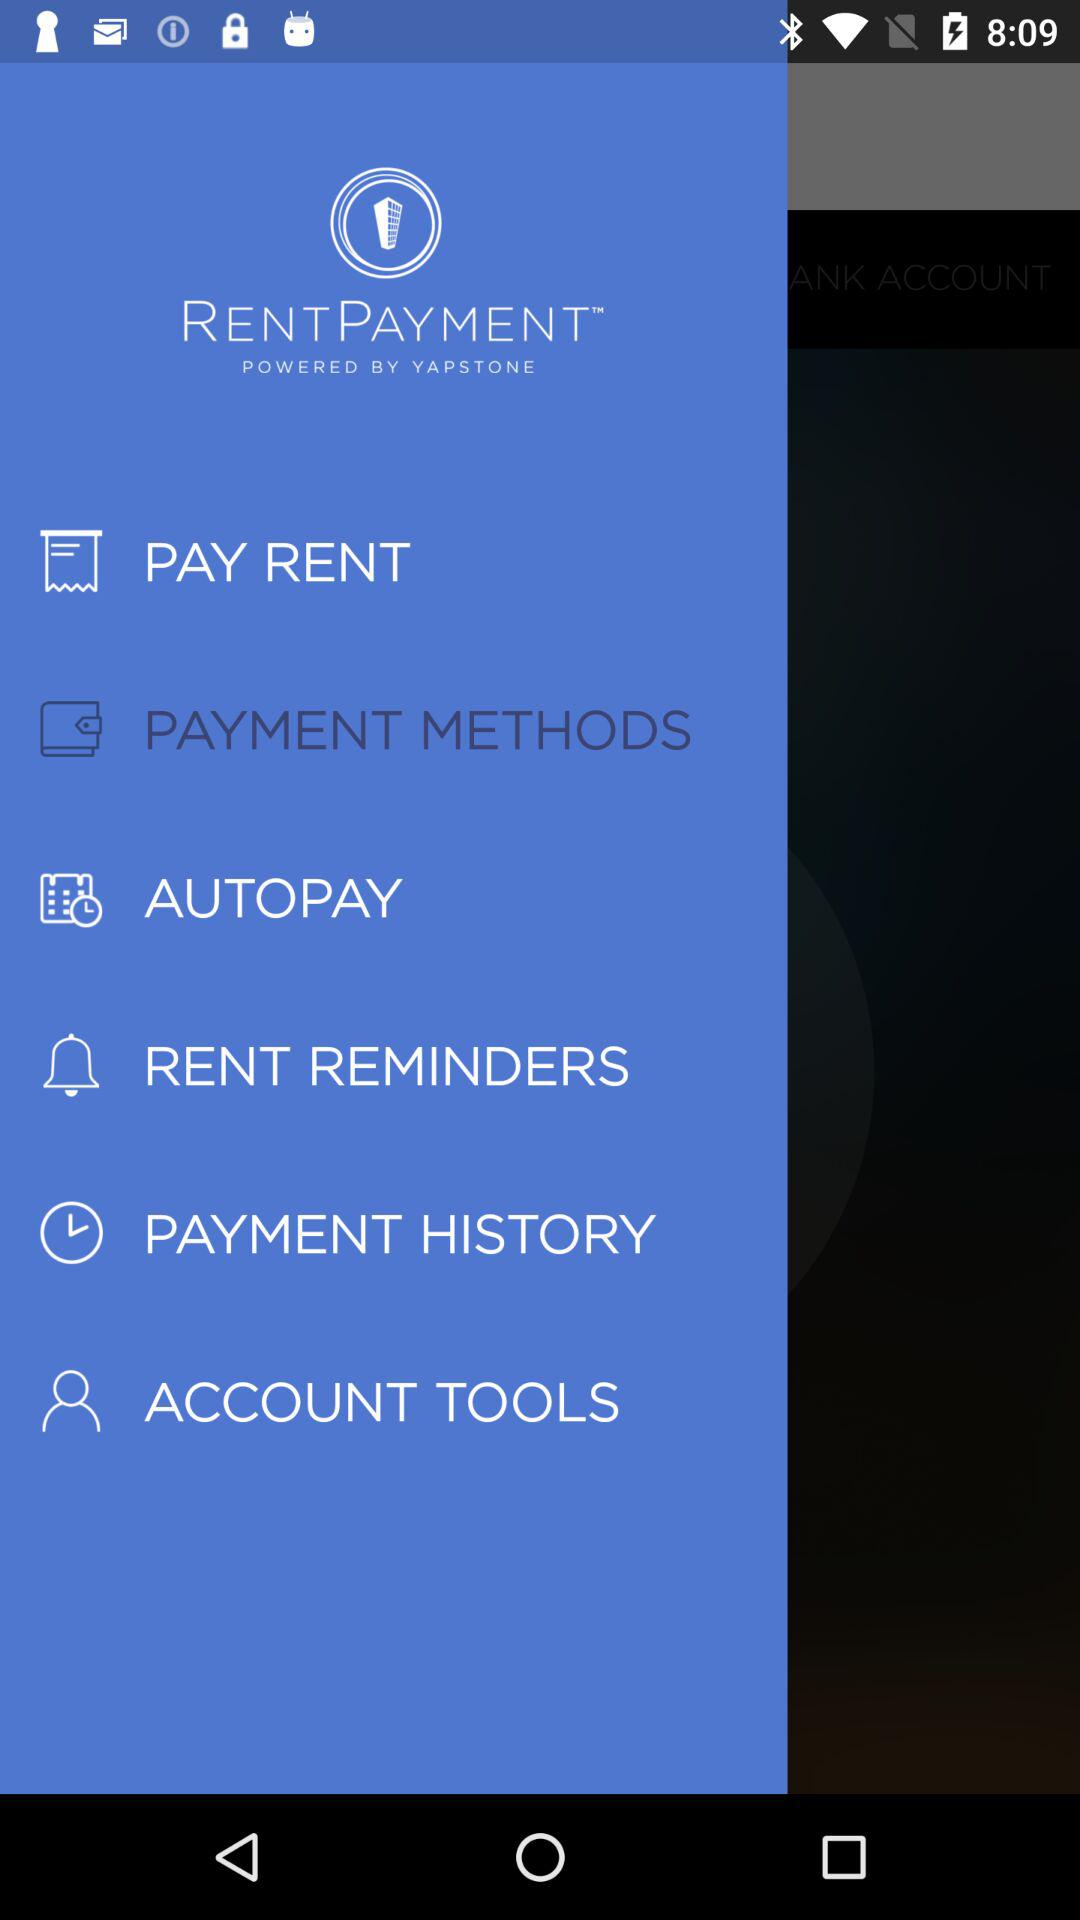What is the application name? The application name is "RENTPAYMENT". 